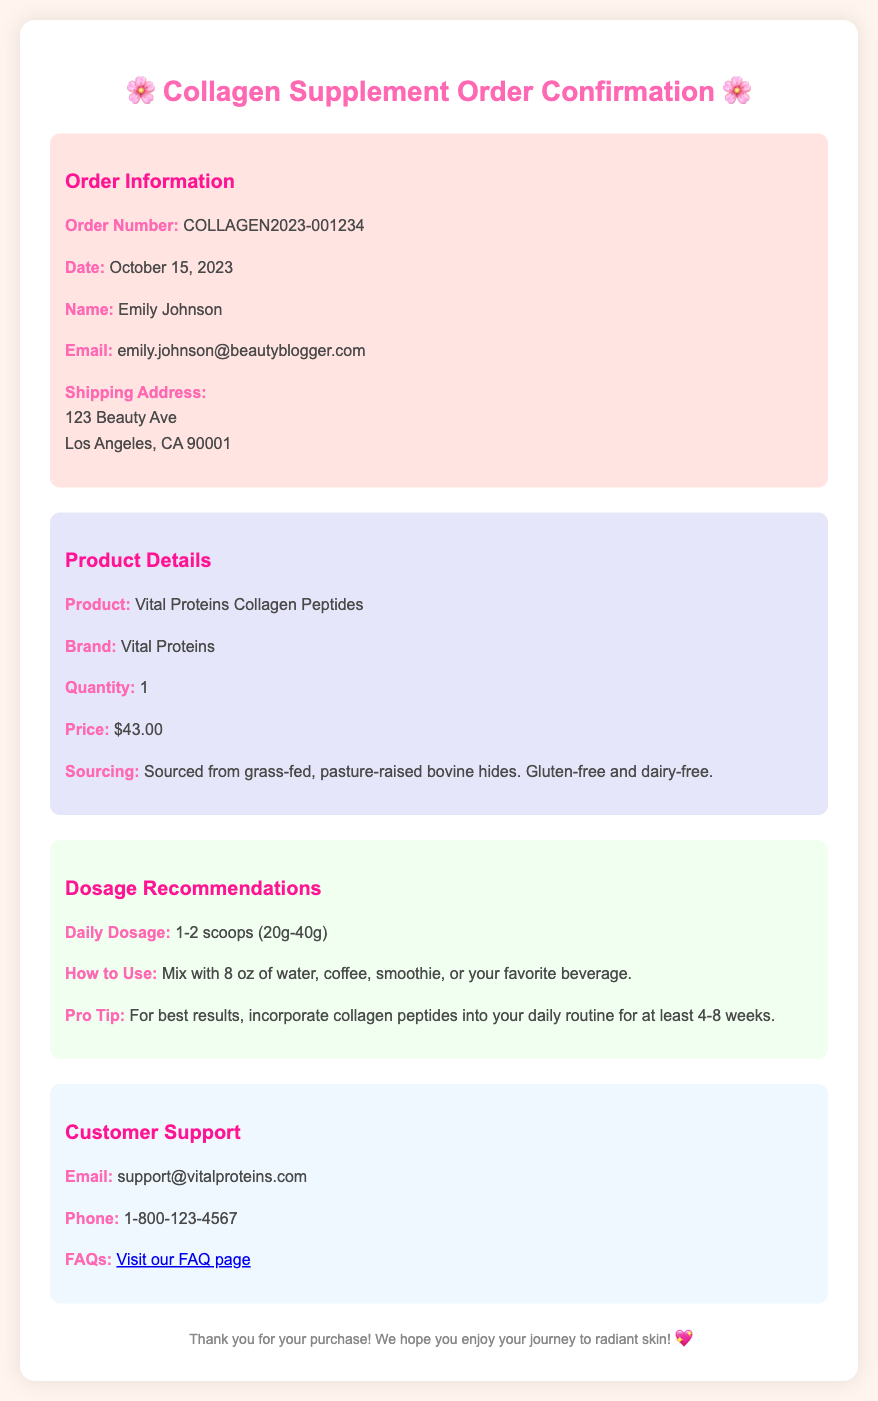what is the order number? The order number is specified in the order details section of the document as COLLAGEN2023-001234.
Answer: COLLAGEN2023-001234 who is the purchaser's name? The purchaser's name can be found in the order details and is Emily Johnson.
Answer: Emily Johnson what is the price of the product? The price of the product is listed in the product details section as $43.00.
Answer: $43.00 what is the daily dosage recommendation? The daily dosage recommendation is detailed in the dosage section and is 1-2 scoops (20g-40g).
Answer: 1-2 scoops (20g-40g) what source is the collagen derived from? The sourcing information indicates the collagen is sourced from grass-fed, pasture-raised bovine hides.
Answer: grass-fed, pasture-raised bovine hides how should the collagen be consumed? The document specifies that the collagen should be mixed with 8 oz of water, coffee, smoothie, or your favorite beverage.
Answer: mix with 8 oz of water, coffee, smoothie, or your favorite beverage how long should collagen peptides be incorporated for best results? The pro tip in the dosage section recommends incorporating collagen peptides into your routine for at least 4-8 weeks.
Answer: 4-8 weeks what is the support email provided in the document? The support email is mentioned in the customer support section and is support@vitalproteins.com.
Answer: support@vitalproteins.com what is the product name listed in the document? The product name is specified in the product details section as Vital Proteins Collagen Peptides.
Answer: Vital Proteins Collagen Peptides 